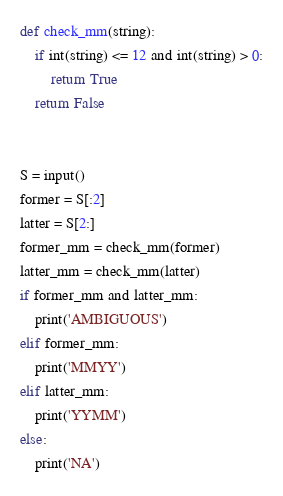<code> <loc_0><loc_0><loc_500><loc_500><_Python_>def check_mm(string):
    if int(string) <= 12 and int(string) > 0:
        return True
    return False


S = input()
former = S[:2]
latter = S[2:]
former_mm = check_mm(former)
latter_mm = check_mm(latter)
if former_mm and latter_mm:
    print('AMBIGUOUS')
elif former_mm:
    print('MMYY')
elif latter_mm:
    print('YYMM')
else:
    print('NA')</code> 